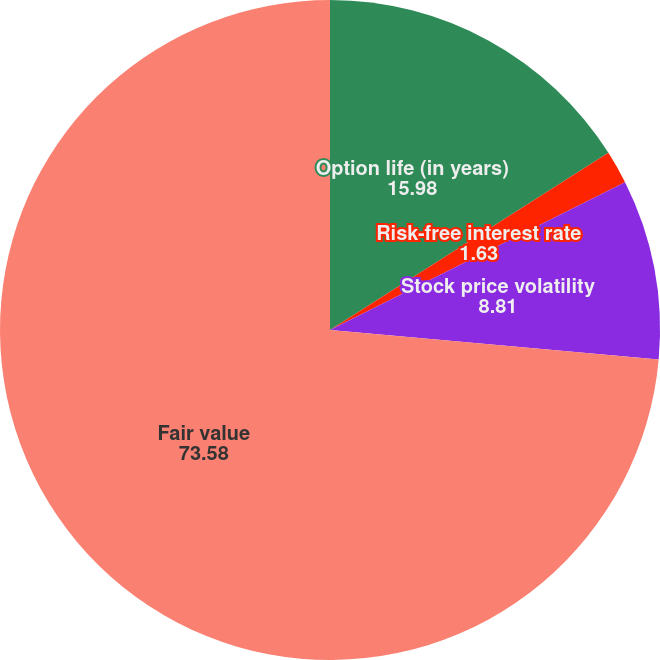<chart> <loc_0><loc_0><loc_500><loc_500><pie_chart><fcel>Option life (in years)<fcel>Risk-free interest rate<fcel>Stock price volatility<fcel>Fair value<nl><fcel>15.98%<fcel>1.63%<fcel>8.81%<fcel>73.58%<nl></chart> 